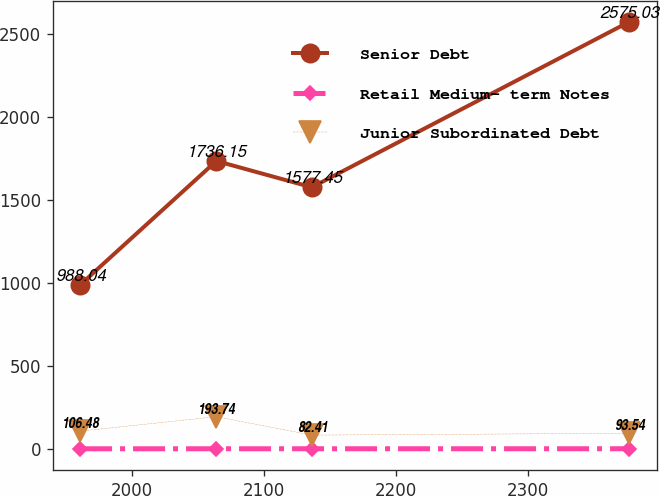Convert chart. <chart><loc_0><loc_0><loc_500><loc_500><line_chart><ecel><fcel>Senior Debt<fcel>Retail Medium- term Notes<fcel>Junior Subordinated Debt<nl><fcel>1960.55<fcel>988.04<fcel>0<fcel>106.48<nl><fcel>2063.86<fcel>1736.15<fcel>0.1<fcel>193.74<nl><fcel>2136.2<fcel>1577.45<fcel>0.2<fcel>82.41<nl><fcel>2376.63<fcel>2575.03<fcel>0.3<fcel>93.54<nl></chart> 